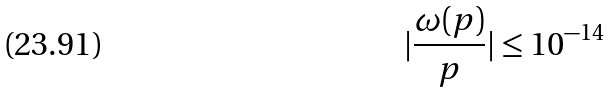<formula> <loc_0><loc_0><loc_500><loc_500>| \frac { \omega ( p ) } { p } | \leq 1 0 ^ { - 1 4 }</formula> 